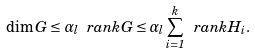<formula> <loc_0><loc_0><loc_500><loc_500>\dim G \leq \alpha _ { l } \ r a n k G \leq \alpha _ { l } \sum _ { i = 1 } ^ { k } \ r a n k H _ { i } .</formula> 